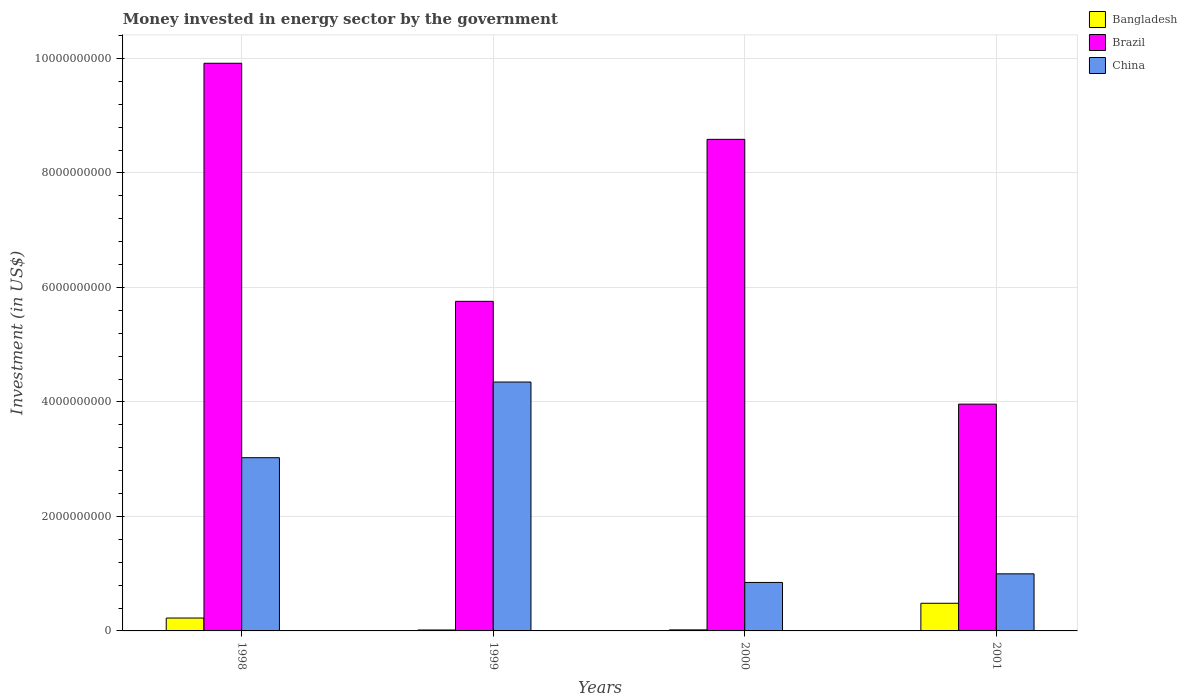How many different coloured bars are there?
Your response must be concise. 3. Are the number of bars on each tick of the X-axis equal?
Ensure brevity in your answer.  Yes. How many bars are there on the 4th tick from the left?
Provide a succinct answer. 3. What is the label of the 4th group of bars from the left?
Your answer should be compact. 2001. In how many cases, is the number of bars for a given year not equal to the number of legend labels?
Your answer should be compact. 0. What is the money spent in energy sector in China in 2001?
Offer a very short reply. 9.97e+08. Across all years, what is the maximum money spent in energy sector in China?
Make the answer very short. 4.35e+09. Across all years, what is the minimum money spent in energy sector in Brazil?
Keep it short and to the point. 3.96e+09. In which year was the money spent in energy sector in Bangladesh maximum?
Keep it short and to the point. 2001. What is the total money spent in energy sector in Brazil in the graph?
Your answer should be very brief. 2.82e+1. What is the difference between the money spent in energy sector in Bangladesh in 1999 and that in 2000?
Keep it short and to the point. -2.35e+06. What is the difference between the money spent in energy sector in Brazil in 2000 and the money spent in energy sector in China in 1999?
Provide a short and direct response. 4.24e+09. What is the average money spent in energy sector in China per year?
Provide a short and direct response. 2.30e+09. In the year 2000, what is the difference between the money spent in energy sector in Bangladesh and money spent in energy sector in Brazil?
Your answer should be very brief. -8.57e+09. What is the ratio of the money spent in energy sector in Bangladesh in 1998 to that in 2000?
Keep it short and to the point. 12.16. Is the money spent in energy sector in Bangladesh in 1998 less than that in 2000?
Your answer should be very brief. No. What is the difference between the highest and the second highest money spent in energy sector in China?
Provide a succinct answer. 1.32e+09. What is the difference between the highest and the lowest money spent in energy sector in Brazil?
Offer a terse response. 5.95e+09. In how many years, is the money spent in energy sector in Brazil greater than the average money spent in energy sector in Brazil taken over all years?
Provide a short and direct response. 2. What does the 2nd bar from the left in 2000 represents?
Ensure brevity in your answer.  Brazil. Is it the case that in every year, the sum of the money spent in energy sector in Bangladesh and money spent in energy sector in China is greater than the money spent in energy sector in Brazil?
Provide a succinct answer. No. How many bars are there?
Offer a terse response. 12. Are all the bars in the graph horizontal?
Your answer should be very brief. No. How many years are there in the graph?
Provide a short and direct response. 4. What is the difference between two consecutive major ticks on the Y-axis?
Make the answer very short. 2.00e+09. Does the graph contain grids?
Ensure brevity in your answer.  Yes. How many legend labels are there?
Provide a succinct answer. 3. How are the legend labels stacked?
Offer a terse response. Vertical. What is the title of the graph?
Keep it short and to the point. Money invested in energy sector by the government. What is the label or title of the Y-axis?
Keep it short and to the point. Investment (in US$). What is the Investment (in US$) in Bangladesh in 1998?
Provide a short and direct response. 2.25e+08. What is the Investment (in US$) in Brazil in 1998?
Provide a succinct answer. 9.92e+09. What is the Investment (in US$) of China in 1998?
Provide a short and direct response. 3.03e+09. What is the Investment (in US$) of Bangladesh in 1999?
Keep it short and to the point. 1.62e+07. What is the Investment (in US$) of Brazil in 1999?
Provide a succinct answer. 5.76e+09. What is the Investment (in US$) of China in 1999?
Offer a very short reply. 4.35e+09. What is the Investment (in US$) in Bangladesh in 2000?
Keep it short and to the point. 1.85e+07. What is the Investment (in US$) in Brazil in 2000?
Provide a short and direct response. 8.59e+09. What is the Investment (in US$) of China in 2000?
Provide a succinct answer. 8.47e+08. What is the Investment (in US$) in Bangladesh in 2001?
Offer a terse response. 4.83e+08. What is the Investment (in US$) in Brazil in 2001?
Provide a short and direct response. 3.96e+09. What is the Investment (in US$) in China in 2001?
Provide a succinct answer. 9.97e+08. Across all years, what is the maximum Investment (in US$) of Bangladesh?
Make the answer very short. 4.83e+08. Across all years, what is the maximum Investment (in US$) in Brazil?
Ensure brevity in your answer.  9.92e+09. Across all years, what is the maximum Investment (in US$) in China?
Make the answer very short. 4.35e+09. Across all years, what is the minimum Investment (in US$) in Bangladesh?
Your response must be concise. 1.62e+07. Across all years, what is the minimum Investment (in US$) of Brazil?
Provide a succinct answer. 3.96e+09. Across all years, what is the minimum Investment (in US$) of China?
Ensure brevity in your answer.  8.47e+08. What is the total Investment (in US$) of Bangladesh in the graph?
Offer a very short reply. 7.43e+08. What is the total Investment (in US$) in Brazil in the graph?
Give a very brief answer. 2.82e+1. What is the total Investment (in US$) in China in the graph?
Provide a succinct answer. 9.22e+09. What is the difference between the Investment (in US$) in Bangladesh in 1998 and that in 1999?
Make the answer very short. 2.09e+08. What is the difference between the Investment (in US$) in Brazil in 1998 and that in 1999?
Offer a very short reply. 4.16e+09. What is the difference between the Investment (in US$) of China in 1998 and that in 1999?
Offer a terse response. -1.32e+09. What is the difference between the Investment (in US$) of Bangladesh in 1998 and that in 2000?
Give a very brief answer. 2.06e+08. What is the difference between the Investment (in US$) in Brazil in 1998 and that in 2000?
Make the answer very short. 1.33e+09. What is the difference between the Investment (in US$) of China in 1998 and that in 2000?
Provide a short and direct response. 2.18e+09. What is the difference between the Investment (in US$) in Bangladesh in 1998 and that in 2001?
Your response must be concise. -2.58e+08. What is the difference between the Investment (in US$) of Brazil in 1998 and that in 2001?
Your response must be concise. 5.95e+09. What is the difference between the Investment (in US$) of China in 1998 and that in 2001?
Give a very brief answer. 2.03e+09. What is the difference between the Investment (in US$) in Bangladesh in 1999 and that in 2000?
Give a very brief answer. -2.35e+06. What is the difference between the Investment (in US$) in Brazil in 1999 and that in 2000?
Your response must be concise. -2.83e+09. What is the difference between the Investment (in US$) of China in 1999 and that in 2000?
Offer a terse response. 3.50e+09. What is the difference between the Investment (in US$) of Bangladesh in 1999 and that in 2001?
Keep it short and to the point. -4.67e+08. What is the difference between the Investment (in US$) in Brazil in 1999 and that in 2001?
Offer a terse response. 1.80e+09. What is the difference between the Investment (in US$) of China in 1999 and that in 2001?
Keep it short and to the point. 3.35e+09. What is the difference between the Investment (in US$) in Bangladesh in 2000 and that in 2001?
Offer a very short reply. -4.64e+08. What is the difference between the Investment (in US$) of Brazil in 2000 and that in 2001?
Your response must be concise. 4.63e+09. What is the difference between the Investment (in US$) in China in 2000 and that in 2001?
Offer a terse response. -1.50e+08. What is the difference between the Investment (in US$) of Bangladesh in 1998 and the Investment (in US$) of Brazil in 1999?
Your answer should be very brief. -5.53e+09. What is the difference between the Investment (in US$) of Bangladesh in 1998 and the Investment (in US$) of China in 1999?
Ensure brevity in your answer.  -4.12e+09. What is the difference between the Investment (in US$) in Brazil in 1998 and the Investment (in US$) in China in 1999?
Offer a terse response. 5.57e+09. What is the difference between the Investment (in US$) of Bangladesh in 1998 and the Investment (in US$) of Brazil in 2000?
Your answer should be compact. -8.36e+09. What is the difference between the Investment (in US$) of Bangladesh in 1998 and the Investment (in US$) of China in 2000?
Offer a terse response. -6.22e+08. What is the difference between the Investment (in US$) of Brazil in 1998 and the Investment (in US$) of China in 2000?
Your answer should be very brief. 9.07e+09. What is the difference between the Investment (in US$) of Bangladesh in 1998 and the Investment (in US$) of Brazil in 2001?
Give a very brief answer. -3.74e+09. What is the difference between the Investment (in US$) of Bangladesh in 1998 and the Investment (in US$) of China in 2001?
Make the answer very short. -7.72e+08. What is the difference between the Investment (in US$) of Brazil in 1998 and the Investment (in US$) of China in 2001?
Ensure brevity in your answer.  8.92e+09. What is the difference between the Investment (in US$) in Bangladesh in 1999 and the Investment (in US$) in Brazil in 2000?
Provide a short and direct response. -8.57e+09. What is the difference between the Investment (in US$) of Bangladesh in 1999 and the Investment (in US$) of China in 2000?
Your response must be concise. -8.31e+08. What is the difference between the Investment (in US$) in Brazil in 1999 and the Investment (in US$) in China in 2000?
Give a very brief answer. 4.91e+09. What is the difference between the Investment (in US$) of Bangladesh in 1999 and the Investment (in US$) of Brazil in 2001?
Provide a short and direct response. -3.95e+09. What is the difference between the Investment (in US$) in Bangladesh in 1999 and the Investment (in US$) in China in 2001?
Keep it short and to the point. -9.81e+08. What is the difference between the Investment (in US$) in Brazil in 1999 and the Investment (in US$) in China in 2001?
Make the answer very short. 4.76e+09. What is the difference between the Investment (in US$) of Bangladesh in 2000 and the Investment (in US$) of Brazil in 2001?
Offer a very short reply. -3.94e+09. What is the difference between the Investment (in US$) of Bangladesh in 2000 and the Investment (in US$) of China in 2001?
Offer a very short reply. -9.79e+08. What is the difference between the Investment (in US$) in Brazil in 2000 and the Investment (in US$) in China in 2001?
Ensure brevity in your answer.  7.59e+09. What is the average Investment (in US$) of Bangladesh per year?
Keep it short and to the point. 1.86e+08. What is the average Investment (in US$) of Brazil per year?
Provide a short and direct response. 7.06e+09. What is the average Investment (in US$) of China per year?
Give a very brief answer. 2.30e+09. In the year 1998, what is the difference between the Investment (in US$) of Bangladesh and Investment (in US$) of Brazil?
Provide a short and direct response. -9.69e+09. In the year 1998, what is the difference between the Investment (in US$) of Bangladesh and Investment (in US$) of China?
Offer a very short reply. -2.80e+09. In the year 1998, what is the difference between the Investment (in US$) of Brazil and Investment (in US$) of China?
Your answer should be very brief. 6.89e+09. In the year 1999, what is the difference between the Investment (in US$) in Bangladesh and Investment (in US$) in Brazil?
Provide a short and direct response. -5.74e+09. In the year 1999, what is the difference between the Investment (in US$) in Bangladesh and Investment (in US$) in China?
Offer a very short reply. -4.33e+09. In the year 1999, what is the difference between the Investment (in US$) of Brazil and Investment (in US$) of China?
Give a very brief answer. 1.41e+09. In the year 2000, what is the difference between the Investment (in US$) in Bangladesh and Investment (in US$) in Brazil?
Give a very brief answer. -8.57e+09. In the year 2000, what is the difference between the Investment (in US$) in Bangladesh and Investment (in US$) in China?
Ensure brevity in your answer.  -8.28e+08. In the year 2000, what is the difference between the Investment (in US$) of Brazil and Investment (in US$) of China?
Provide a succinct answer. 7.74e+09. In the year 2001, what is the difference between the Investment (in US$) of Bangladesh and Investment (in US$) of Brazil?
Provide a succinct answer. -3.48e+09. In the year 2001, what is the difference between the Investment (in US$) of Bangladesh and Investment (in US$) of China?
Keep it short and to the point. -5.14e+08. In the year 2001, what is the difference between the Investment (in US$) in Brazil and Investment (in US$) in China?
Give a very brief answer. 2.96e+09. What is the ratio of the Investment (in US$) in Bangladesh in 1998 to that in 1999?
Your response must be concise. 13.93. What is the ratio of the Investment (in US$) in Brazil in 1998 to that in 1999?
Your answer should be compact. 1.72. What is the ratio of the Investment (in US$) of China in 1998 to that in 1999?
Offer a terse response. 0.7. What is the ratio of the Investment (in US$) of Bangladesh in 1998 to that in 2000?
Make the answer very short. 12.16. What is the ratio of the Investment (in US$) in Brazil in 1998 to that in 2000?
Give a very brief answer. 1.15. What is the ratio of the Investment (in US$) of China in 1998 to that in 2000?
Offer a terse response. 3.57. What is the ratio of the Investment (in US$) in Bangladesh in 1998 to that in 2001?
Offer a terse response. 0.47. What is the ratio of the Investment (in US$) of Brazil in 1998 to that in 2001?
Your answer should be compact. 2.5. What is the ratio of the Investment (in US$) of China in 1998 to that in 2001?
Offer a very short reply. 3.03. What is the ratio of the Investment (in US$) in Bangladesh in 1999 to that in 2000?
Provide a short and direct response. 0.87. What is the ratio of the Investment (in US$) of Brazil in 1999 to that in 2000?
Make the answer very short. 0.67. What is the ratio of the Investment (in US$) of China in 1999 to that in 2000?
Your response must be concise. 5.13. What is the ratio of the Investment (in US$) of Bangladesh in 1999 to that in 2001?
Your answer should be very brief. 0.03. What is the ratio of the Investment (in US$) of Brazil in 1999 to that in 2001?
Your answer should be very brief. 1.45. What is the ratio of the Investment (in US$) of China in 1999 to that in 2001?
Your answer should be compact. 4.36. What is the ratio of the Investment (in US$) in Bangladesh in 2000 to that in 2001?
Provide a succinct answer. 0.04. What is the ratio of the Investment (in US$) of Brazil in 2000 to that in 2001?
Ensure brevity in your answer.  2.17. What is the ratio of the Investment (in US$) in China in 2000 to that in 2001?
Make the answer very short. 0.85. What is the difference between the highest and the second highest Investment (in US$) in Bangladesh?
Your answer should be very brief. 2.58e+08. What is the difference between the highest and the second highest Investment (in US$) in Brazil?
Give a very brief answer. 1.33e+09. What is the difference between the highest and the second highest Investment (in US$) of China?
Ensure brevity in your answer.  1.32e+09. What is the difference between the highest and the lowest Investment (in US$) of Bangladesh?
Offer a very short reply. 4.67e+08. What is the difference between the highest and the lowest Investment (in US$) of Brazil?
Your answer should be compact. 5.95e+09. What is the difference between the highest and the lowest Investment (in US$) of China?
Your answer should be compact. 3.50e+09. 